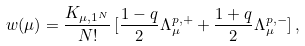Convert formula to latex. <formula><loc_0><loc_0><loc_500><loc_500>w ( \mu ) = \frac { K _ { \mu , 1 ^ { N } } } { N ! } \, [ \frac { 1 - q } { 2 } \Lambda _ { \mu } ^ { p , + } + \frac { 1 + q } { 2 } \Lambda _ { \mu } ^ { p , - } ] \, ,</formula> 